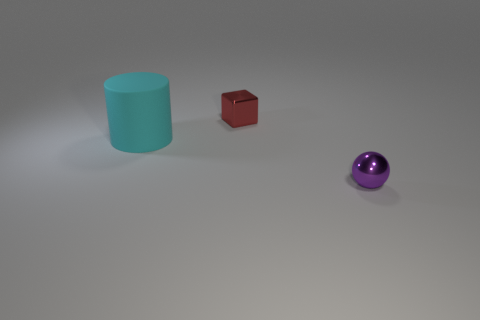Add 2 metallic blocks. How many objects exist? 5 Subtract all blocks. How many objects are left? 2 Add 3 yellow matte balls. How many yellow matte balls exist? 3 Subtract 0 purple cylinders. How many objects are left? 3 Subtract all tiny yellow shiny cylinders. Subtract all small red blocks. How many objects are left? 2 Add 1 metal balls. How many metal balls are left? 2 